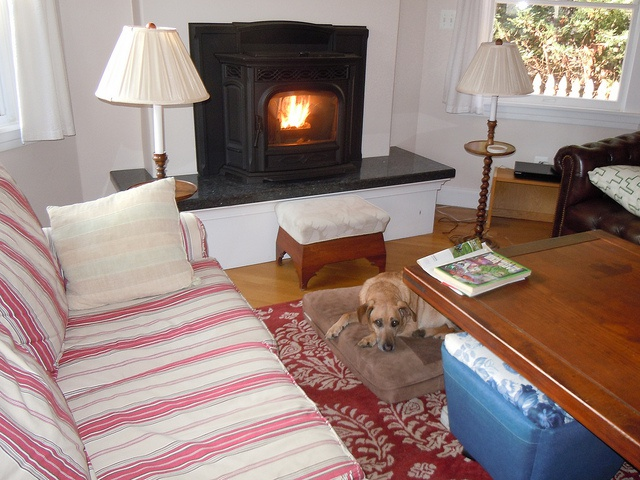Describe the objects in this image and their specific colors. I can see couch in white, lightgray, and darkgray tones, chair in white, black, darkgray, maroon, and gray tones, couch in white, black, darkgray, and gray tones, dog in white, gray, tan, and maroon tones, and book in white, darkgray, ivory, olive, and gray tones in this image. 